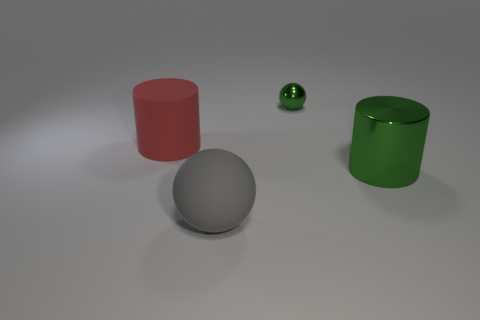Add 2 big green objects. How many objects exist? 6 Add 4 large brown rubber cylinders. How many large brown rubber cylinders exist? 4 Subtract 0 yellow spheres. How many objects are left? 4 Subtract all large red objects. Subtract all green cylinders. How many objects are left? 2 Add 1 gray things. How many gray things are left? 2 